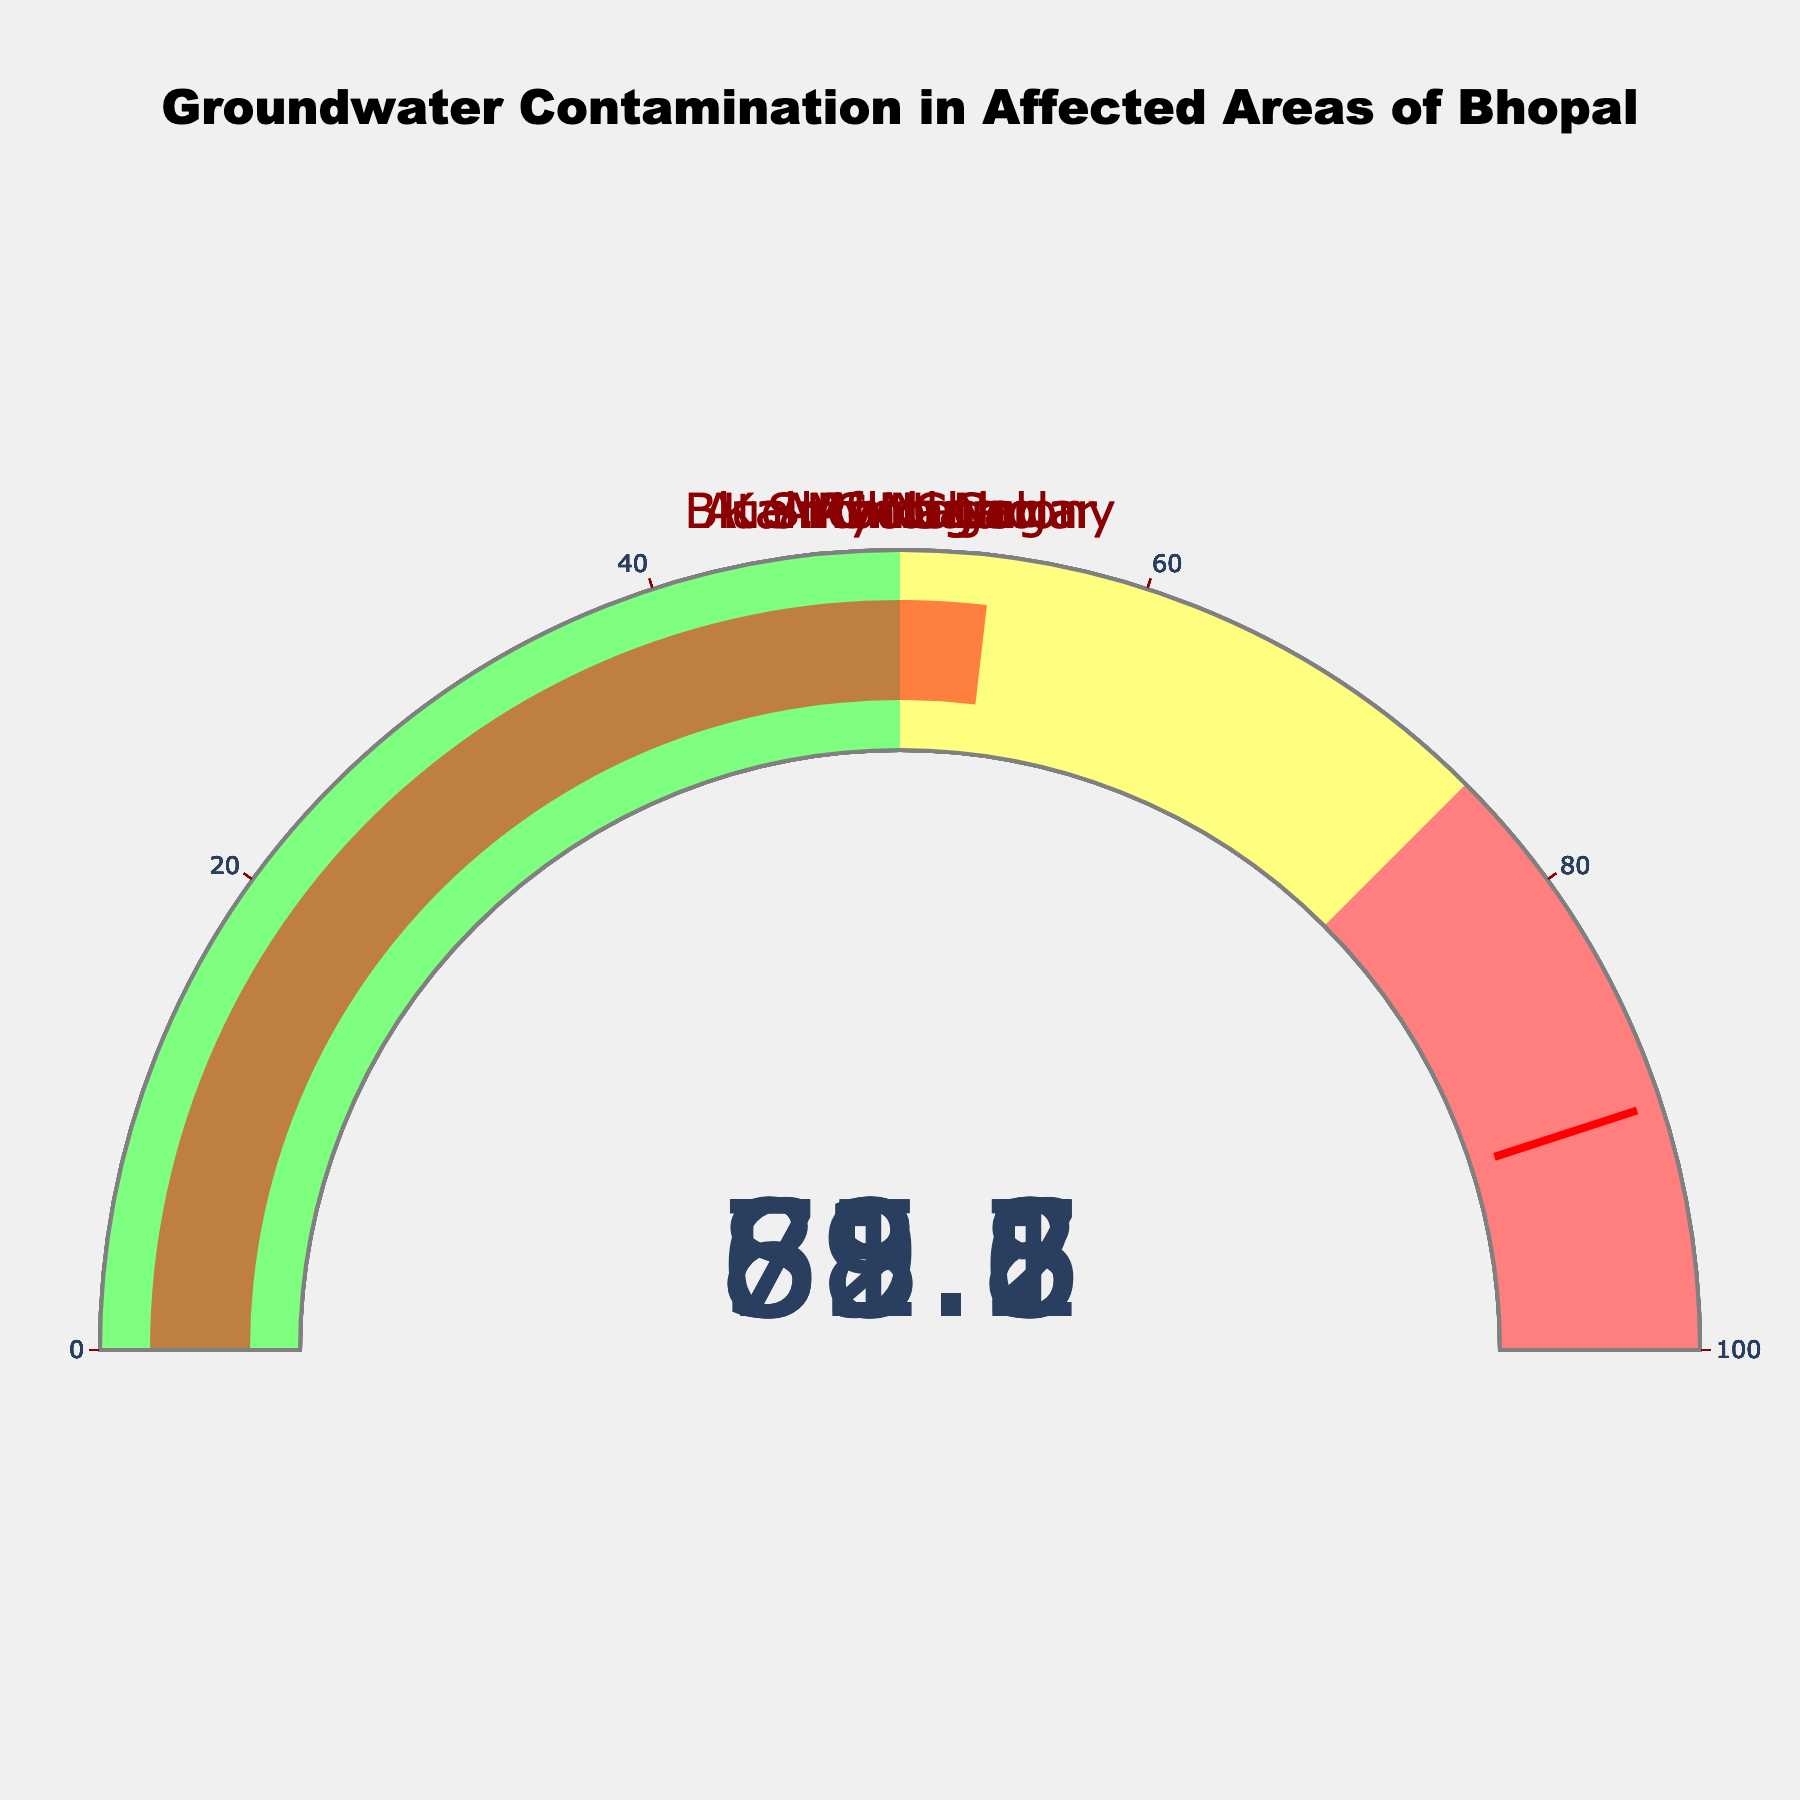What's the contamination level in J.P. Nagar? The gauge chart corresponding to J.P. Nagar shows the contamination level. It reads 78.5%.
Answer: 78.5% Which area has the highest groundwater contamination? By examining all the gauges, Arif Nagar has the highest percentage at 88.6%.
Answer: Arif Nagar Which areas have contamination levels above 80%? By checking each gauge, Shiv Nagar (82.1%) and Arif Nagar (88.6%) have levels above 80%.
Answer: Shiv Nagar, Arif Nagar What is the average contamination percentage across all areas? Sum the contamination percentages (78.5 + 65.2 + 82.1 + 59.8 + 71.3 + 88.6 + 53.7) and divide by the number of areas (7). The calculation is (499.2/7).
Answer: 71.31% Which area's contamination level is closest to the warning threshold of 90%? Compare the contamination levels to 90%. Arif Nagar at 88.6% is the closest.
Answer: Arif Nagar Is Blue Moon Colony's contamination higher or lower than Kainchi Chhola's? Blue Moon Colony shows 59.8% while Kainchi Chhola shows 53.7%, so Blue Moon Colony is higher.
Answer: Higher What is the contamination variance among the listed areas? First, find the mean (71.31%), then use the formula for variance: [(78.5-71.31)^2 + (65.2-71.31)^2 + (82.1-71.31)^2 + (59.8-71.31)^2 + (71.3-71.31)^2 + (88.6-71.31)^2 + (53.7-71.31)^2]/7 which simplifies to 120.27.
Answer: 120.27 What color represents contamination levels between 75% to 100%? Observing the color bars in the gauges, contamination levels from 75% to 100% are marked in a shade of red.
Answer: Red 